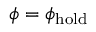<formula> <loc_0><loc_0><loc_500><loc_500>\phi = \phi _ { h o l d }</formula> 